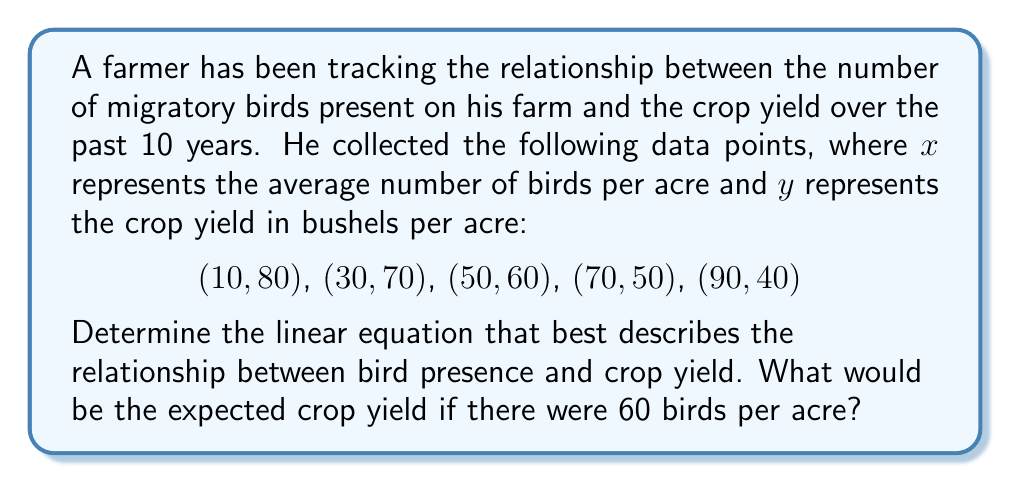Can you solve this math problem? To find the linear equation, we'll use the slope-intercept form: $y = mx + b$

Step 1: Calculate the slope $(m)$
Using the first and last data points: $(10, 80)$ and $(90, 40)$
$$m = \frac{y_2 - y_1}{x_2 - x_1} = \frac{40 - 80}{90 - 10} = \frac{-40}{80} = -0.5$$

Step 2: Find the y-intercept $(b)$
Use the point-slope form with $(10, 80)$:
$$y - 80 = -0.5(x - 10)$$
$$y = -0.5x + 5 + 80$$
$$y = -0.5x + 85$$

Step 3: Write the linear equation
$$y = -0.5x + 85$$

Step 4: Calculate the expected crop yield for 60 birds per acre
$$y = -0.5(60) + 85 = -30 + 85 = 55$$

Therefore, the expected crop yield for 60 birds per acre is 55 bushels per acre.
Answer: $y = -0.5x + 85$; 55 bushels per acre 